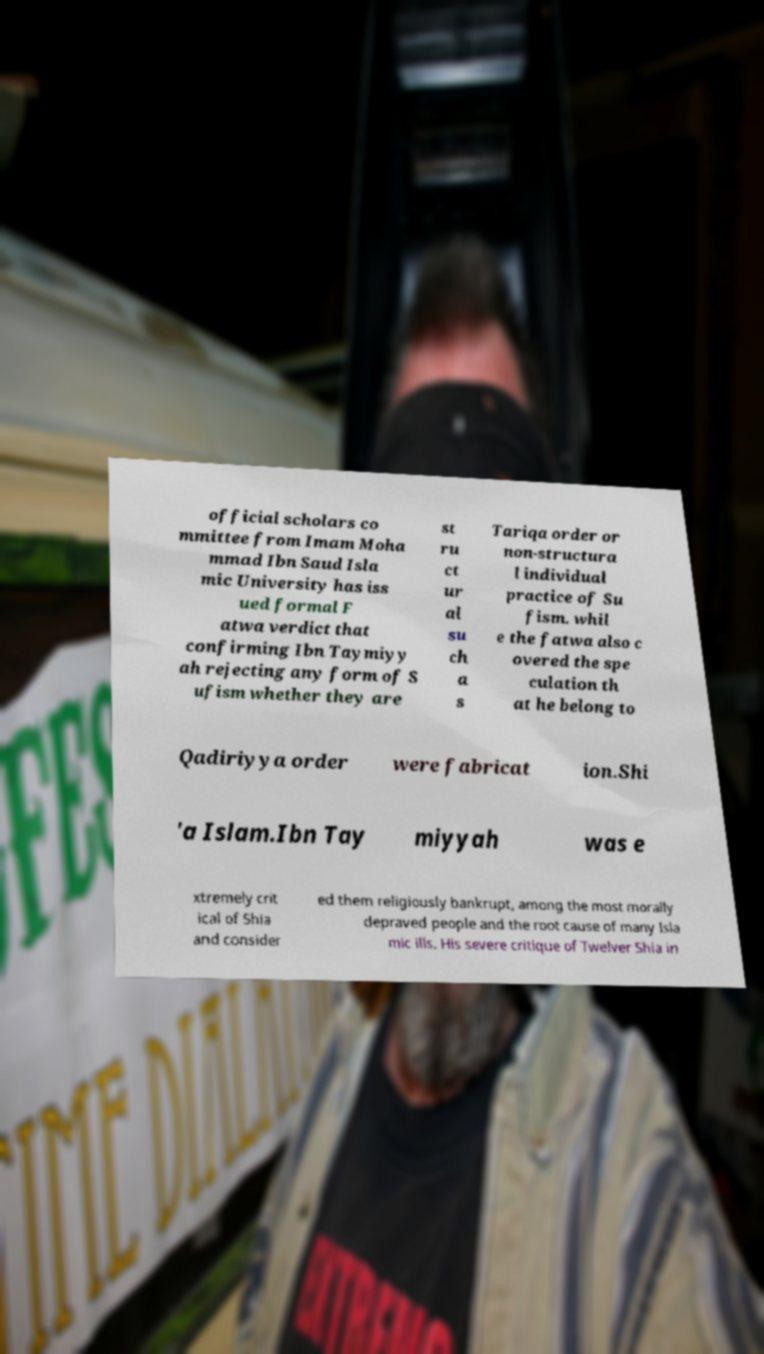Could you extract and type out the text from this image? official scholars co mmittee from Imam Moha mmad Ibn Saud Isla mic University has iss ued formal F atwa verdict that confirming Ibn Taymiyy ah rejecting any form of S ufism whether they are st ru ct ur al su ch a s Tariqa order or non-structura l individual practice of Su fism. whil e the fatwa also c overed the spe culation th at he belong to Qadiriyya order were fabricat ion.Shi 'a Islam.Ibn Tay miyyah was e xtremely crit ical of Shia and consider ed them religiously bankrupt, among the most morally depraved people and the root cause of many Isla mic ills. His severe critique of Twelver Shia in 